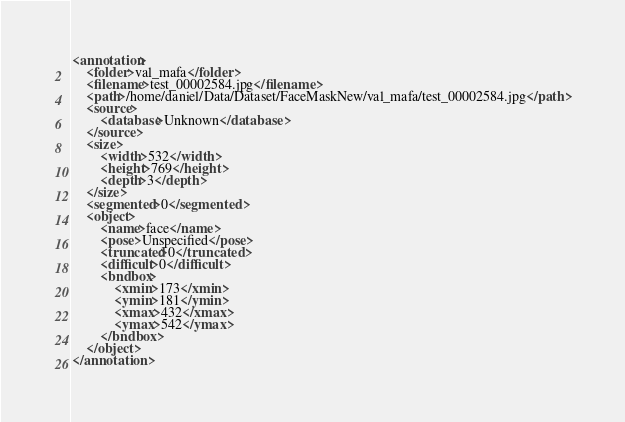<code> <loc_0><loc_0><loc_500><loc_500><_XML_><annotation>
	<folder>val_mafa</folder>
	<filename>test_00002584.jpg</filename>
	<path>/home/daniel/Data/Dataset/FaceMaskNew/val_mafa/test_00002584.jpg</path>
	<source>
		<database>Unknown</database>
	</source>
	<size>
		<width>532</width>
		<height>769</height>
		<depth>3</depth>
	</size>
	<segmented>0</segmented>
	<object>
		<name>face</name>
		<pose>Unspecified</pose>
		<truncated>0</truncated>
		<difficult>0</difficult>
		<bndbox>
			<xmin>173</xmin>
			<ymin>181</ymin>
			<xmax>432</xmax>
			<ymax>542</ymax>
		</bndbox>
	</object>
</annotation>
</code> 